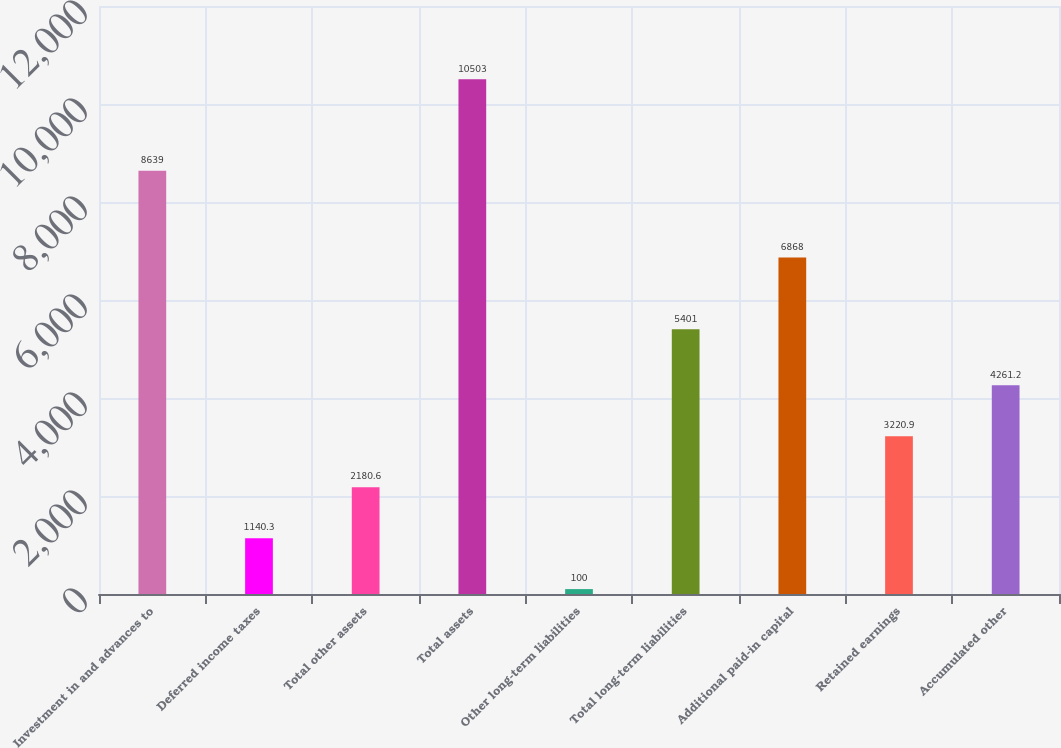Convert chart to OTSL. <chart><loc_0><loc_0><loc_500><loc_500><bar_chart><fcel>Investment in and advances to<fcel>Deferred income taxes<fcel>Total other assets<fcel>Total assets<fcel>Other long-term liabilities<fcel>Total long-term liabilities<fcel>Additional paid-in capital<fcel>Retained earnings<fcel>Accumulated other<nl><fcel>8639<fcel>1140.3<fcel>2180.6<fcel>10503<fcel>100<fcel>5401<fcel>6868<fcel>3220.9<fcel>4261.2<nl></chart> 